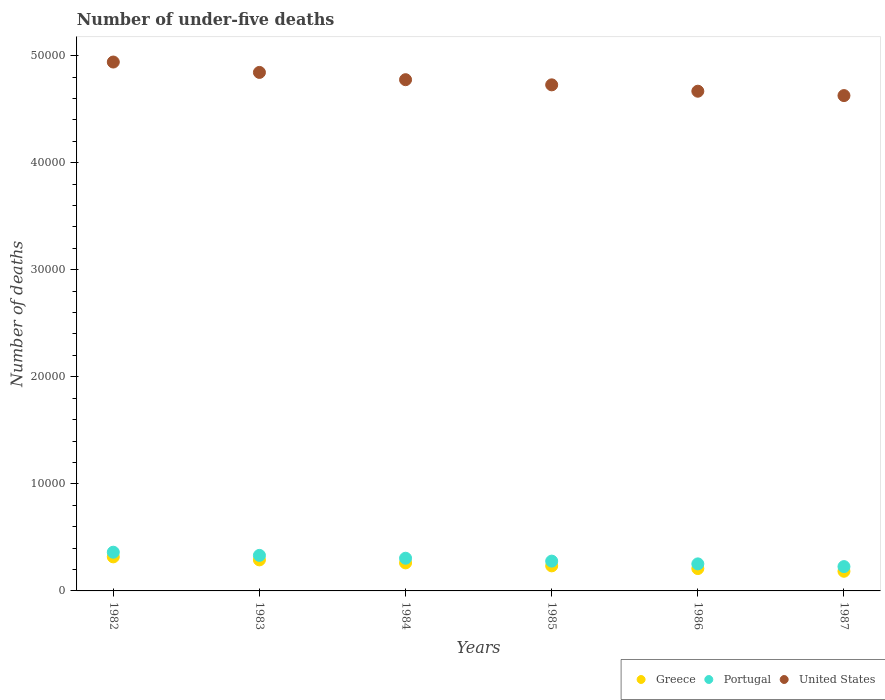How many different coloured dotlines are there?
Your answer should be compact. 3. Is the number of dotlines equal to the number of legend labels?
Ensure brevity in your answer.  Yes. What is the number of under-five deaths in Greece in 1984?
Keep it short and to the point. 2618. Across all years, what is the maximum number of under-five deaths in Portugal?
Your response must be concise. 3616. Across all years, what is the minimum number of under-five deaths in Greece?
Make the answer very short. 1837. What is the total number of under-five deaths in Greece in the graph?
Provide a short and direct response. 1.50e+04. What is the difference between the number of under-five deaths in Portugal in 1982 and that in 1986?
Offer a very short reply. 1090. What is the difference between the number of under-five deaths in United States in 1983 and the number of under-five deaths in Greece in 1987?
Your answer should be compact. 4.66e+04. What is the average number of under-five deaths in Portugal per year?
Your answer should be very brief. 2928.17. In the year 1987, what is the difference between the number of under-five deaths in Greece and number of under-five deaths in United States?
Ensure brevity in your answer.  -4.44e+04. In how many years, is the number of under-five deaths in Portugal greater than 18000?
Keep it short and to the point. 0. What is the ratio of the number of under-five deaths in Portugal in 1985 to that in 1987?
Offer a terse response. 1.22. Is the number of under-five deaths in Greece in 1983 less than that in 1985?
Your response must be concise. No. Is the difference between the number of under-five deaths in Greece in 1985 and 1987 greater than the difference between the number of under-five deaths in United States in 1985 and 1987?
Make the answer very short. No. What is the difference between the highest and the second highest number of under-five deaths in Greece?
Offer a terse response. 283. What is the difference between the highest and the lowest number of under-five deaths in United States?
Offer a very short reply. 3134. In how many years, is the number of under-five deaths in United States greater than the average number of under-five deaths in United States taken over all years?
Offer a terse response. 3. Is the sum of the number of under-five deaths in Greece in 1985 and 1987 greater than the maximum number of under-five deaths in United States across all years?
Offer a very short reply. No. Is the number of under-five deaths in United States strictly greater than the number of under-five deaths in Portugal over the years?
Offer a very short reply. Yes. Are the values on the major ticks of Y-axis written in scientific E-notation?
Offer a terse response. No. Does the graph contain any zero values?
Your response must be concise. No. Does the graph contain grids?
Offer a very short reply. No. Where does the legend appear in the graph?
Your answer should be compact. Bottom right. How many legend labels are there?
Give a very brief answer. 3. How are the legend labels stacked?
Your answer should be very brief. Horizontal. What is the title of the graph?
Your answer should be very brief. Number of under-five deaths. What is the label or title of the Y-axis?
Ensure brevity in your answer.  Number of deaths. What is the Number of deaths in Greece in 1982?
Provide a short and direct response. 3181. What is the Number of deaths in Portugal in 1982?
Ensure brevity in your answer.  3616. What is the Number of deaths in United States in 1982?
Make the answer very short. 4.94e+04. What is the Number of deaths of Greece in 1983?
Make the answer very short. 2898. What is the Number of deaths of Portugal in 1983?
Offer a very short reply. 3319. What is the Number of deaths in United States in 1983?
Offer a very short reply. 4.84e+04. What is the Number of deaths in Greece in 1984?
Your answer should be compact. 2618. What is the Number of deaths in Portugal in 1984?
Offer a very short reply. 3053. What is the Number of deaths in United States in 1984?
Provide a succinct answer. 4.77e+04. What is the Number of deaths in Greece in 1985?
Make the answer very short. 2340. What is the Number of deaths of Portugal in 1985?
Provide a succinct answer. 2783. What is the Number of deaths in United States in 1985?
Your response must be concise. 4.73e+04. What is the Number of deaths of Greece in 1986?
Your response must be concise. 2088. What is the Number of deaths in Portugal in 1986?
Provide a short and direct response. 2526. What is the Number of deaths of United States in 1986?
Make the answer very short. 4.67e+04. What is the Number of deaths in Greece in 1987?
Your answer should be very brief. 1837. What is the Number of deaths in Portugal in 1987?
Ensure brevity in your answer.  2272. What is the Number of deaths in United States in 1987?
Ensure brevity in your answer.  4.63e+04. Across all years, what is the maximum Number of deaths in Greece?
Provide a succinct answer. 3181. Across all years, what is the maximum Number of deaths of Portugal?
Offer a very short reply. 3616. Across all years, what is the maximum Number of deaths in United States?
Ensure brevity in your answer.  4.94e+04. Across all years, what is the minimum Number of deaths of Greece?
Your response must be concise. 1837. Across all years, what is the minimum Number of deaths in Portugal?
Offer a very short reply. 2272. Across all years, what is the minimum Number of deaths in United States?
Your response must be concise. 4.63e+04. What is the total Number of deaths of Greece in the graph?
Offer a terse response. 1.50e+04. What is the total Number of deaths of Portugal in the graph?
Ensure brevity in your answer.  1.76e+04. What is the total Number of deaths in United States in the graph?
Offer a very short reply. 2.86e+05. What is the difference between the Number of deaths of Greece in 1982 and that in 1983?
Offer a very short reply. 283. What is the difference between the Number of deaths of Portugal in 1982 and that in 1983?
Ensure brevity in your answer.  297. What is the difference between the Number of deaths of United States in 1982 and that in 1983?
Provide a succinct answer. 969. What is the difference between the Number of deaths in Greece in 1982 and that in 1984?
Give a very brief answer. 563. What is the difference between the Number of deaths in Portugal in 1982 and that in 1984?
Keep it short and to the point. 563. What is the difference between the Number of deaths of United States in 1982 and that in 1984?
Provide a short and direct response. 1649. What is the difference between the Number of deaths in Greece in 1982 and that in 1985?
Give a very brief answer. 841. What is the difference between the Number of deaths in Portugal in 1982 and that in 1985?
Offer a very short reply. 833. What is the difference between the Number of deaths in United States in 1982 and that in 1985?
Give a very brief answer. 2131. What is the difference between the Number of deaths of Greece in 1982 and that in 1986?
Offer a terse response. 1093. What is the difference between the Number of deaths in Portugal in 1982 and that in 1986?
Your answer should be very brief. 1090. What is the difference between the Number of deaths of United States in 1982 and that in 1986?
Provide a succinct answer. 2725. What is the difference between the Number of deaths of Greece in 1982 and that in 1987?
Give a very brief answer. 1344. What is the difference between the Number of deaths of Portugal in 1982 and that in 1987?
Your response must be concise. 1344. What is the difference between the Number of deaths of United States in 1982 and that in 1987?
Offer a very short reply. 3134. What is the difference between the Number of deaths in Greece in 1983 and that in 1984?
Your response must be concise. 280. What is the difference between the Number of deaths in Portugal in 1983 and that in 1984?
Ensure brevity in your answer.  266. What is the difference between the Number of deaths of United States in 1983 and that in 1984?
Make the answer very short. 680. What is the difference between the Number of deaths of Greece in 1983 and that in 1985?
Your response must be concise. 558. What is the difference between the Number of deaths in Portugal in 1983 and that in 1985?
Give a very brief answer. 536. What is the difference between the Number of deaths in United States in 1983 and that in 1985?
Keep it short and to the point. 1162. What is the difference between the Number of deaths of Greece in 1983 and that in 1986?
Keep it short and to the point. 810. What is the difference between the Number of deaths of Portugal in 1983 and that in 1986?
Your response must be concise. 793. What is the difference between the Number of deaths of United States in 1983 and that in 1986?
Your answer should be very brief. 1756. What is the difference between the Number of deaths in Greece in 1983 and that in 1987?
Your answer should be very brief. 1061. What is the difference between the Number of deaths in Portugal in 1983 and that in 1987?
Your answer should be compact. 1047. What is the difference between the Number of deaths in United States in 1983 and that in 1987?
Provide a succinct answer. 2165. What is the difference between the Number of deaths in Greece in 1984 and that in 1985?
Provide a short and direct response. 278. What is the difference between the Number of deaths of Portugal in 1984 and that in 1985?
Offer a very short reply. 270. What is the difference between the Number of deaths of United States in 1984 and that in 1985?
Offer a very short reply. 482. What is the difference between the Number of deaths in Greece in 1984 and that in 1986?
Keep it short and to the point. 530. What is the difference between the Number of deaths in Portugal in 1984 and that in 1986?
Provide a short and direct response. 527. What is the difference between the Number of deaths in United States in 1984 and that in 1986?
Your response must be concise. 1076. What is the difference between the Number of deaths in Greece in 1984 and that in 1987?
Offer a very short reply. 781. What is the difference between the Number of deaths in Portugal in 1984 and that in 1987?
Give a very brief answer. 781. What is the difference between the Number of deaths in United States in 1984 and that in 1987?
Provide a short and direct response. 1485. What is the difference between the Number of deaths of Greece in 1985 and that in 1986?
Give a very brief answer. 252. What is the difference between the Number of deaths in Portugal in 1985 and that in 1986?
Your response must be concise. 257. What is the difference between the Number of deaths of United States in 1985 and that in 1986?
Keep it short and to the point. 594. What is the difference between the Number of deaths of Greece in 1985 and that in 1987?
Make the answer very short. 503. What is the difference between the Number of deaths in Portugal in 1985 and that in 1987?
Your answer should be very brief. 511. What is the difference between the Number of deaths of United States in 1985 and that in 1987?
Ensure brevity in your answer.  1003. What is the difference between the Number of deaths of Greece in 1986 and that in 1987?
Your response must be concise. 251. What is the difference between the Number of deaths in Portugal in 1986 and that in 1987?
Provide a succinct answer. 254. What is the difference between the Number of deaths of United States in 1986 and that in 1987?
Your answer should be very brief. 409. What is the difference between the Number of deaths of Greece in 1982 and the Number of deaths of Portugal in 1983?
Your response must be concise. -138. What is the difference between the Number of deaths of Greece in 1982 and the Number of deaths of United States in 1983?
Offer a very short reply. -4.52e+04. What is the difference between the Number of deaths of Portugal in 1982 and the Number of deaths of United States in 1983?
Offer a terse response. -4.48e+04. What is the difference between the Number of deaths of Greece in 1982 and the Number of deaths of Portugal in 1984?
Provide a short and direct response. 128. What is the difference between the Number of deaths in Greece in 1982 and the Number of deaths in United States in 1984?
Your answer should be very brief. -4.46e+04. What is the difference between the Number of deaths of Portugal in 1982 and the Number of deaths of United States in 1984?
Your answer should be compact. -4.41e+04. What is the difference between the Number of deaths in Greece in 1982 and the Number of deaths in Portugal in 1985?
Ensure brevity in your answer.  398. What is the difference between the Number of deaths in Greece in 1982 and the Number of deaths in United States in 1985?
Give a very brief answer. -4.41e+04. What is the difference between the Number of deaths of Portugal in 1982 and the Number of deaths of United States in 1985?
Offer a terse response. -4.37e+04. What is the difference between the Number of deaths of Greece in 1982 and the Number of deaths of Portugal in 1986?
Your answer should be very brief. 655. What is the difference between the Number of deaths in Greece in 1982 and the Number of deaths in United States in 1986?
Your response must be concise. -4.35e+04. What is the difference between the Number of deaths in Portugal in 1982 and the Number of deaths in United States in 1986?
Offer a very short reply. -4.31e+04. What is the difference between the Number of deaths in Greece in 1982 and the Number of deaths in Portugal in 1987?
Provide a succinct answer. 909. What is the difference between the Number of deaths of Greece in 1982 and the Number of deaths of United States in 1987?
Your response must be concise. -4.31e+04. What is the difference between the Number of deaths in Portugal in 1982 and the Number of deaths in United States in 1987?
Offer a terse response. -4.26e+04. What is the difference between the Number of deaths of Greece in 1983 and the Number of deaths of Portugal in 1984?
Ensure brevity in your answer.  -155. What is the difference between the Number of deaths in Greece in 1983 and the Number of deaths in United States in 1984?
Provide a short and direct response. -4.49e+04. What is the difference between the Number of deaths of Portugal in 1983 and the Number of deaths of United States in 1984?
Provide a short and direct response. -4.44e+04. What is the difference between the Number of deaths of Greece in 1983 and the Number of deaths of Portugal in 1985?
Your response must be concise. 115. What is the difference between the Number of deaths in Greece in 1983 and the Number of deaths in United States in 1985?
Your answer should be very brief. -4.44e+04. What is the difference between the Number of deaths in Portugal in 1983 and the Number of deaths in United States in 1985?
Your answer should be very brief. -4.39e+04. What is the difference between the Number of deaths of Greece in 1983 and the Number of deaths of Portugal in 1986?
Ensure brevity in your answer.  372. What is the difference between the Number of deaths of Greece in 1983 and the Number of deaths of United States in 1986?
Ensure brevity in your answer.  -4.38e+04. What is the difference between the Number of deaths of Portugal in 1983 and the Number of deaths of United States in 1986?
Give a very brief answer. -4.34e+04. What is the difference between the Number of deaths in Greece in 1983 and the Number of deaths in Portugal in 1987?
Give a very brief answer. 626. What is the difference between the Number of deaths in Greece in 1983 and the Number of deaths in United States in 1987?
Offer a very short reply. -4.34e+04. What is the difference between the Number of deaths of Portugal in 1983 and the Number of deaths of United States in 1987?
Provide a succinct answer. -4.29e+04. What is the difference between the Number of deaths in Greece in 1984 and the Number of deaths in Portugal in 1985?
Provide a succinct answer. -165. What is the difference between the Number of deaths in Greece in 1984 and the Number of deaths in United States in 1985?
Your answer should be very brief. -4.46e+04. What is the difference between the Number of deaths in Portugal in 1984 and the Number of deaths in United States in 1985?
Your answer should be very brief. -4.42e+04. What is the difference between the Number of deaths of Greece in 1984 and the Number of deaths of Portugal in 1986?
Keep it short and to the point. 92. What is the difference between the Number of deaths in Greece in 1984 and the Number of deaths in United States in 1986?
Ensure brevity in your answer.  -4.41e+04. What is the difference between the Number of deaths in Portugal in 1984 and the Number of deaths in United States in 1986?
Your answer should be compact. -4.36e+04. What is the difference between the Number of deaths in Greece in 1984 and the Number of deaths in Portugal in 1987?
Your response must be concise. 346. What is the difference between the Number of deaths in Greece in 1984 and the Number of deaths in United States in 1987?
Keep it short and to the point. -4.36e+04. What is the difference between the Number of deaths of Portugal in 1984 and the Number of deaths of United States in 1987?
Your response must be concise. -4.32e+04. What is the difference between the Number of deaths of Greece in 1985 and the Number of deaths of Portugal in 1986?
Provide a short and direct response. -186. What is the difference between the Number of deaths in Greece in 1985 and the Number of deaths in United States in 1986?
Offer a very short reply. -4.43e+04. What is the difference between the Number of deaths in Portugal in 1985 and the Number of deaths in United States in 1986?
Give a very brief answer. -4.39e+04. What is the difference between the Number of deaths in Greece in 1985 and the Number of deaths in Portugal in 1987?
Keep it short and to the point. 68. What is the difference between the Number of deaths of Greece in 1985 and the Number of deaths of United States in 1987?
Your answer should be compact. -4.39e+04. What is the difference between the Number of deaths in Portugal in 1985 and the Number of deaths in United States in 1987?
Offer a terse response. -4.35e+04. What is the difference between the Number of deaths of Greece in 1986 and the Number of deaths of Portugal in 1987?
Provide a succinct answer. -184. What is the difference between the Number of deaths of Greece in 1986 and the Number of deaths of United States in 1987?
Provide a short and direct response. -4.42e+04. What is the difference between the Number of deaths in Portugal in 1986 and the Number of deaths in United States in 1987?
Keep it short and to the point. -4.37e+04. What is the average Number of deaths in Greece per year?
Provide a short and direct response. 2493.67. What is the average Number of deaths of Portugal per year?
Offer a very short reply. 2928.17. What is the average Number of deaths in United States per year?
Provide a succinct answer. 4.76e+04. In the year 1982, what is the difference between the Number of deaths of Greece and Number of deaths of Portugal?
Provide a succinct answer. -435. In the year 1982, what is the difference between the Number of deaths of Greece and Number of deaths of United States?
Your response must be concise. -4.62e+04. In the year 1982, what is the difference between the Number of deaths of Portugal and Number of deaths of United States?
Offer a terse response. -4.58e+04. In the year 1983, what is the difference between the Number of deaths of Greece and Number of deaths of Portugal?
Keep it short and to the point. -421. In the year 1983, what is the difference between the Number of deaths in Greece and Number of deaths in United States?
Provide a short and direct response. -4.55e+04. In the year 1983, what is the difference between the Number of deaths of Portugal and Number of deaths of United States?
Make the answer very short. -4.51e+04. In the year 1984, what is the difference between the Number of deaths of Greece and Number of deaths of Portugal?
Offer a very short reply. -435. In the year 1984, what is the difference between the Number of deaths of Greece and Number of deaths of United States?
Your answer should be very brief. -4.51e+04. In the year 1984, what is the difference between the Number of deaths in Portugal and Number of deaths in United States?
Keep it short and to the point. -4.47e+04. In the year 1985, what is the difference between the Number of deaths in Greece and Number of deaths in Portugal?
Your answer should be compact. -443. In the year 1985, what is the difference between the Number of deaths in Greece and Number of deaths in United States?
Keep it short and to the point. -4.49e+04. In the year 1985, what is the difference between the Number of deaths in Portugal and Number of deaths in United States?
Give a very brief answer. -4.45e+04. In the year 1986, what is the difference between the Number of deaths in Greece and Number of deaths in Portugal?
Your response must be concise. -438. In the year 1986, what is the difference between the Number of deaths in Greece and Number of deaths in United States?
Your answer should be compact. -4.46e+04. In the year 1986, what is the difference between the Number of deaths in Portugal and Number of deaths in United States?
Your answer should be compact. -4.41e+04. In the year 1987, what is the difference between the Number of deaths of Greece and Number of deaths of Portugal?
Offer a terse response. -435. In the year 1987, what is the difference between the Number of deaths of Greece and Number of deaths of United States?
Your answer should be very brief. -4.44e+04. In the year 1987, what is the difference between the Number of deaths in Portugal and Number of deaths in United States?
Provide a short and direct response. -4.40e+04. What is the ratio of the Number of deaths of Greece in 1982 to that in 1983?
Ensure brevity in your answer.  1.1. What is the ratio of the Number of deaths of Portugal in 1982 to that in 1983?
Make the answer very short. 1.09. What is the ratio of the Number of deaths of Greece in 1982 to that in 1984?
Offer a very short reply. 1.22. What is the ratio of the Number of deaths of Portugal in 1982 to that in 1984?
Provide a succinct answer. 1.18. What is the ratio of the Number of deaths of United States in 1982 to that in 1984?
Provide a succinct answer. 1.03. What is the ratio of the Number of deaths in Greece in 1982 to that in 1985?
Provide a succinct answer. 1.36. What is the ratio of the Number of deaths in Portugal in 1982 to that in 1985?
Give a very brief answer. 1.3. What is the ratio of the Number of deaths of United States in 1982 to that in 1985?
Provide a short and direct response. 1.05. What is the ratio of the Number of deaths of Greece in 1982 to that in 1986?
Give a very brief answer. 1.52. What is the ratio of the Number of deaths of Portugal in 1982 to that in 1986?
Offer a very short reply. 1.43. What is the ratio of the Number of deaths of United States in 1982 to that in 1986?
Offer a very short reply. 1.06. What is the ratio of the Number of deaths of Greece in 1982 to that in 1987?
Your answer should be very brief. 1.73. What is the ratio of the Number of deaths of Portugal in 1982 to that in 1987?
Ensure brevity in your answer.  1.59. What is the ratio of the Number of deaths in United States in 1982 to that in 1987?
Provide a short and direct response. 1.07. What is the ratio of the Number of deaths in Greece in 1983 to that in 1984?
Your answer should be very brief. 1.11. What is the ratio of the Number of deaths of Portugal in 1983 to that in 1984?
Your answer should be compact. 1.09. What is the ratio of the Number of deaths in United States in 1983 to that in 1984?
Give a very brief answer. 1.01. What is the ratio of the Number of deaths in Greece in 1983 to that in 1985?
Ensure brevity in your answer.  1.24. What is the ratio of the Number of deaths in Portugal in 1983 to that in 1985?
Your answer should be compact. 1.19. What is the ratio of the Number of deaths in United States in 1983 to that in 1985?
Provide a succinct answer. 1.02. What is the ratio of the Number of deaths in Greece in 1983 to that in 1986?
Your response must be concise. 1.39. What is the ratio of the Number of deaths of Portugal in 1983 to that in 1986?
Your answer should be very brief. 1.31. What is the ratio of the Number of deaths of United States in 1983 to that in 1986?
Offer a very short reply. 1.04. What is the ratio of the Number of deaths in Greece in 1983 to that in 1987?
Your answer should be compact. 1.58. What is the ratio of the Number of deaths of Portugal in 1983 to that in 1987?
Provide a short and direct response. 1.46. What is the ratio of the Number of deaths in United States in 1983 to that in 1987?
Offer a terse response. 1.05. What is the ratio of the Number of deaths of Greece in 1984 to that in 1985?
Your response must be concise. 1.12. What is the ratio of the Number of deaths in Portugal in 1984 to that in 1985?
Ensure brevity in your answer.  1.1. What is the ratio of the Number of deaths in United States in 1984 to that in 1985?
Your response must be concise. 1.01. What is the ratio of the Number of deaths in Greece in 1984 to that in 1986?
Keep it short and to the point. 1.25. What is the ratio of the Number of deaths of Portugal in 1984 to that in 1986?
Keep it short and to the point. 1.21. What is the ratio of the Number of deaths of United States in 1984 to that in 1986?
Provide a short and direct response. 1.02. What is the ratio of the Number of deaths of Greece in 1984 to that in 1987?
Offer a very short reply. 1.43. What is the ratio of the Number of deaths of Portugal in 1984 to that in 1987?
Provide a short and direct response. 1.34. What is the ratio of the Number of deaths of United States in 1984 to that in 1987?
Give a very brief answer. 1.03. What is the ratio of the Number of deaths in Greece in 1985 to that in 1986?
Your answer should be very brief. 1.12. What is the ratio of the Number of deaths in Portugal in 1985 to that in 1986?
Offer a terse response. 1.1. What is the ratio of the Number of deaths of United States in 1985 to that in 1986?
Make the answer very short. 1.01. What is the ratio of the Number of deaths in Greece in 1985 to that in 1987?
Provide a short and direct response. 1.27. What is the ratio of the Number of deaths of Portugal in 1985 to that in 1987?
Make the answer very short. 1.22. What is the ratio of the Number of deaths in United States in 1985 to that in 1987?
Ensure brevity in your answer.  1.02. What is the ratio of the Number of deaths of Greece in 1986 to that in 1987?
Keep it short and to the point. 1.14. What is the ratio of the Number of deaths in Portugal in 1986 to that in 1987?
Your answer should be compact. 1.11. What is the ratio of the Number of deaths in United States in 1986 to that in 1987?
Make the answer very short. 1.01. What is the difference between the highest and the second highest Number of deaths in Greece?
Offer a very short reply. 283. What is the difference between the highest and the second highest Number of deaths of Portugal?
Ensure brevity in your answer.  297. What is the difference between the highest and the second highest Number of deaths of United States?
Provide a short and direct response. 969. What is the difference between the highest and the lowest Number of deaths of Greece?
Offer a very short reply. 1344. What is the difference between the highest and the lowest Number of deaths of Portugal?
Offer a very short reply. 1344. What is the difference between the highest and the lowest Number of deaths of United States?
Offer a very short reply. 3134. 